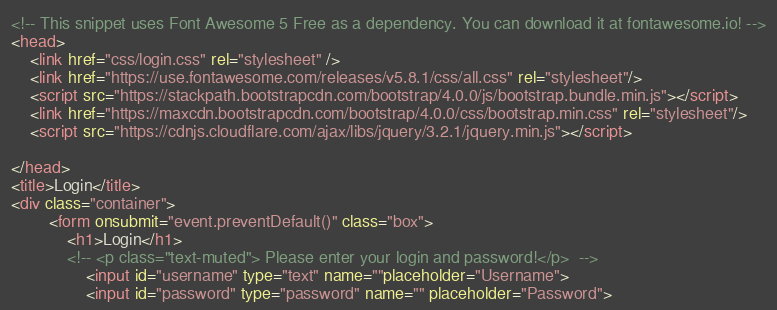<code> <loc_0><loc_0><loc_500><loc_500><_HTML_><!-- This snippet uses Font Awesome 5 Free as a dependency. You can download it at fontawesome.io! -->
<head>
    <link href="css/login.css" rel="stylesheet" />
    <link href="https://use.fontawesome.com/releases/v5.8.1/css/all.css" rel="stylesheet"/>
    <script src="https://stackpath.bootstrapcdn.com/bootstrap/4.0.0/js/bootstrap.bundle.min.js"></script>
    <link href="https://maxcdn.bootstrapcdn.com/bootstrap/4.0.0/css/bootstrap.min.css" rel="stylesheet"/>
    <script src="https://cdnjs.cloudflare.com/ajax/libs/jquery/3.2.1/jquery.min.js"></script>

</head>
<title>Login</title>
<div class="container">
        <form onsubmit="event.preventDefault()" class="box">
            <h1>Login</h1>
            <!-- <p class="text-muted"> Please enter your login and password!</p>  -->
                <input id="username" type="text" name=""placeholder="Username"> 
                <input id="password" type="password" name="" placeholder="Password"> </code> 